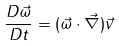<formula> <loc_0><loc_0><loc_500><loc_500>\frac { D \vec { \omega } } { D t } = ( \vec { \omega } \cdot \vec { \nabla } ) \vec { v }</formula> 